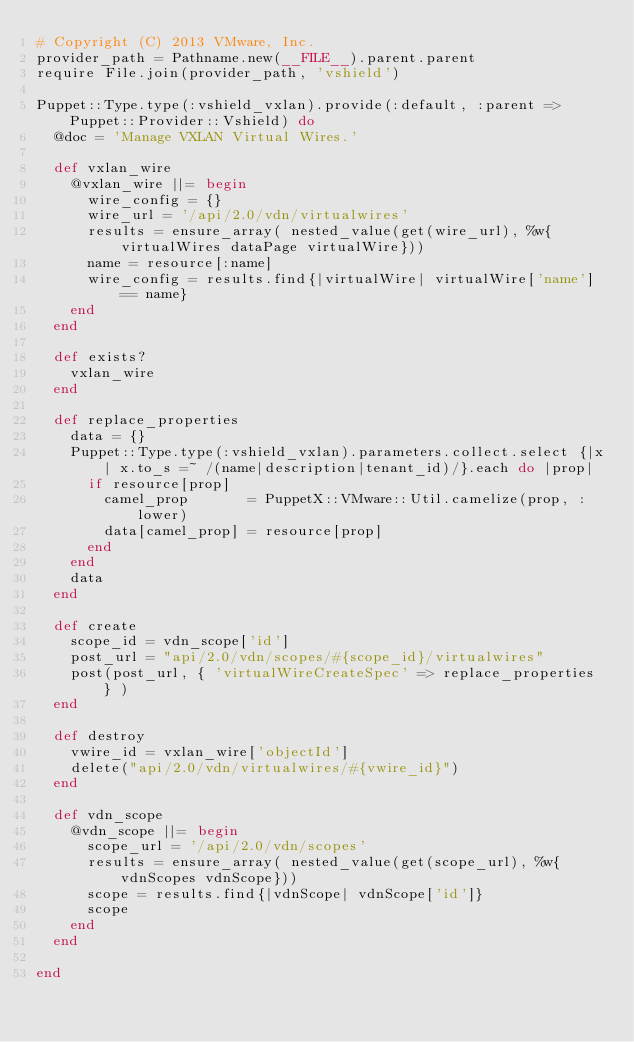Convert code to text. <code><loc_0><loc_0><loc_500><loc_500><_Ruby_># Copyright (C) 2013 VMware, Inc.
provider_path = Pathname.new(__FILE__).parent.parent
require File.join(provider_path, 'vshield')

Puppet::Type.type(:vshield_vxlan).provide(:default, :parent => Puppet::Provider::Vshield) do
  @doc = 'Manage VXLAN Virtual Wires.'

  def vxlan_wire
    @vxlan_wire ||= begin
      wire_config = {}
      wire_url = '/api/2.0/vdn/virtualwires'
      results = ensure_array( nested_value(get(wire_url), %w{virtualWires dataPage virtualWire}))
      name = resource[:name]
      wire_config = results.find{|virtualWire| virtualWire['name'] == name}
    end
  end

  def exists?
    vxlan_wire
  end

  def replace_properties
    data = {}
    Puppet::Type.type(:vshield_vxlan).parameters.collect.select {|x| x.to_s =~ /(name|description|tenant_id)/}.each do |prop|
      if resource[prop]
        camel_prop       = PuppetX::VMware::Util.camelize(prop, :lower)
        data[camel_prop] = resource[prop]
      end
    end
    data
  end

  def create
    scope_id = vdn_scope['id']
    post_url = "api/2.0/vdn/scopes/#{scope_id}/virtualwires"
    post(post_url, { 'virtualWireCreateSpec' => replace_properties } )
  end

  def destroy
    vwire_id = vxlan_wire['objectId']
    delete("api/2.0/vdn/virtualwires/#{vwire_id}")
  end

  def vdn_scope
    @vdn_scope ||= begin
      scope_url = '/api/2.0/vdn/scopes'
      results = ensure_array( nested_value(get(scope_url), %w{vdnScopes vdnScope}))
      scope = results.find{|vdnScope| vdnScope['id']}
      scope
    end
  end

end
</code> 